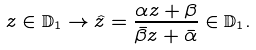<formula> <loc_0><loc_0><loc_500><loc_500>z \in \mathbb { D } _ { 1 } \rightarrow \hat { z } = \frac { \alpha z + \beta } { \bar { \beta } z + \bar { \alpha } } \in \mathbb { D } _ { 1 } .</formula> 